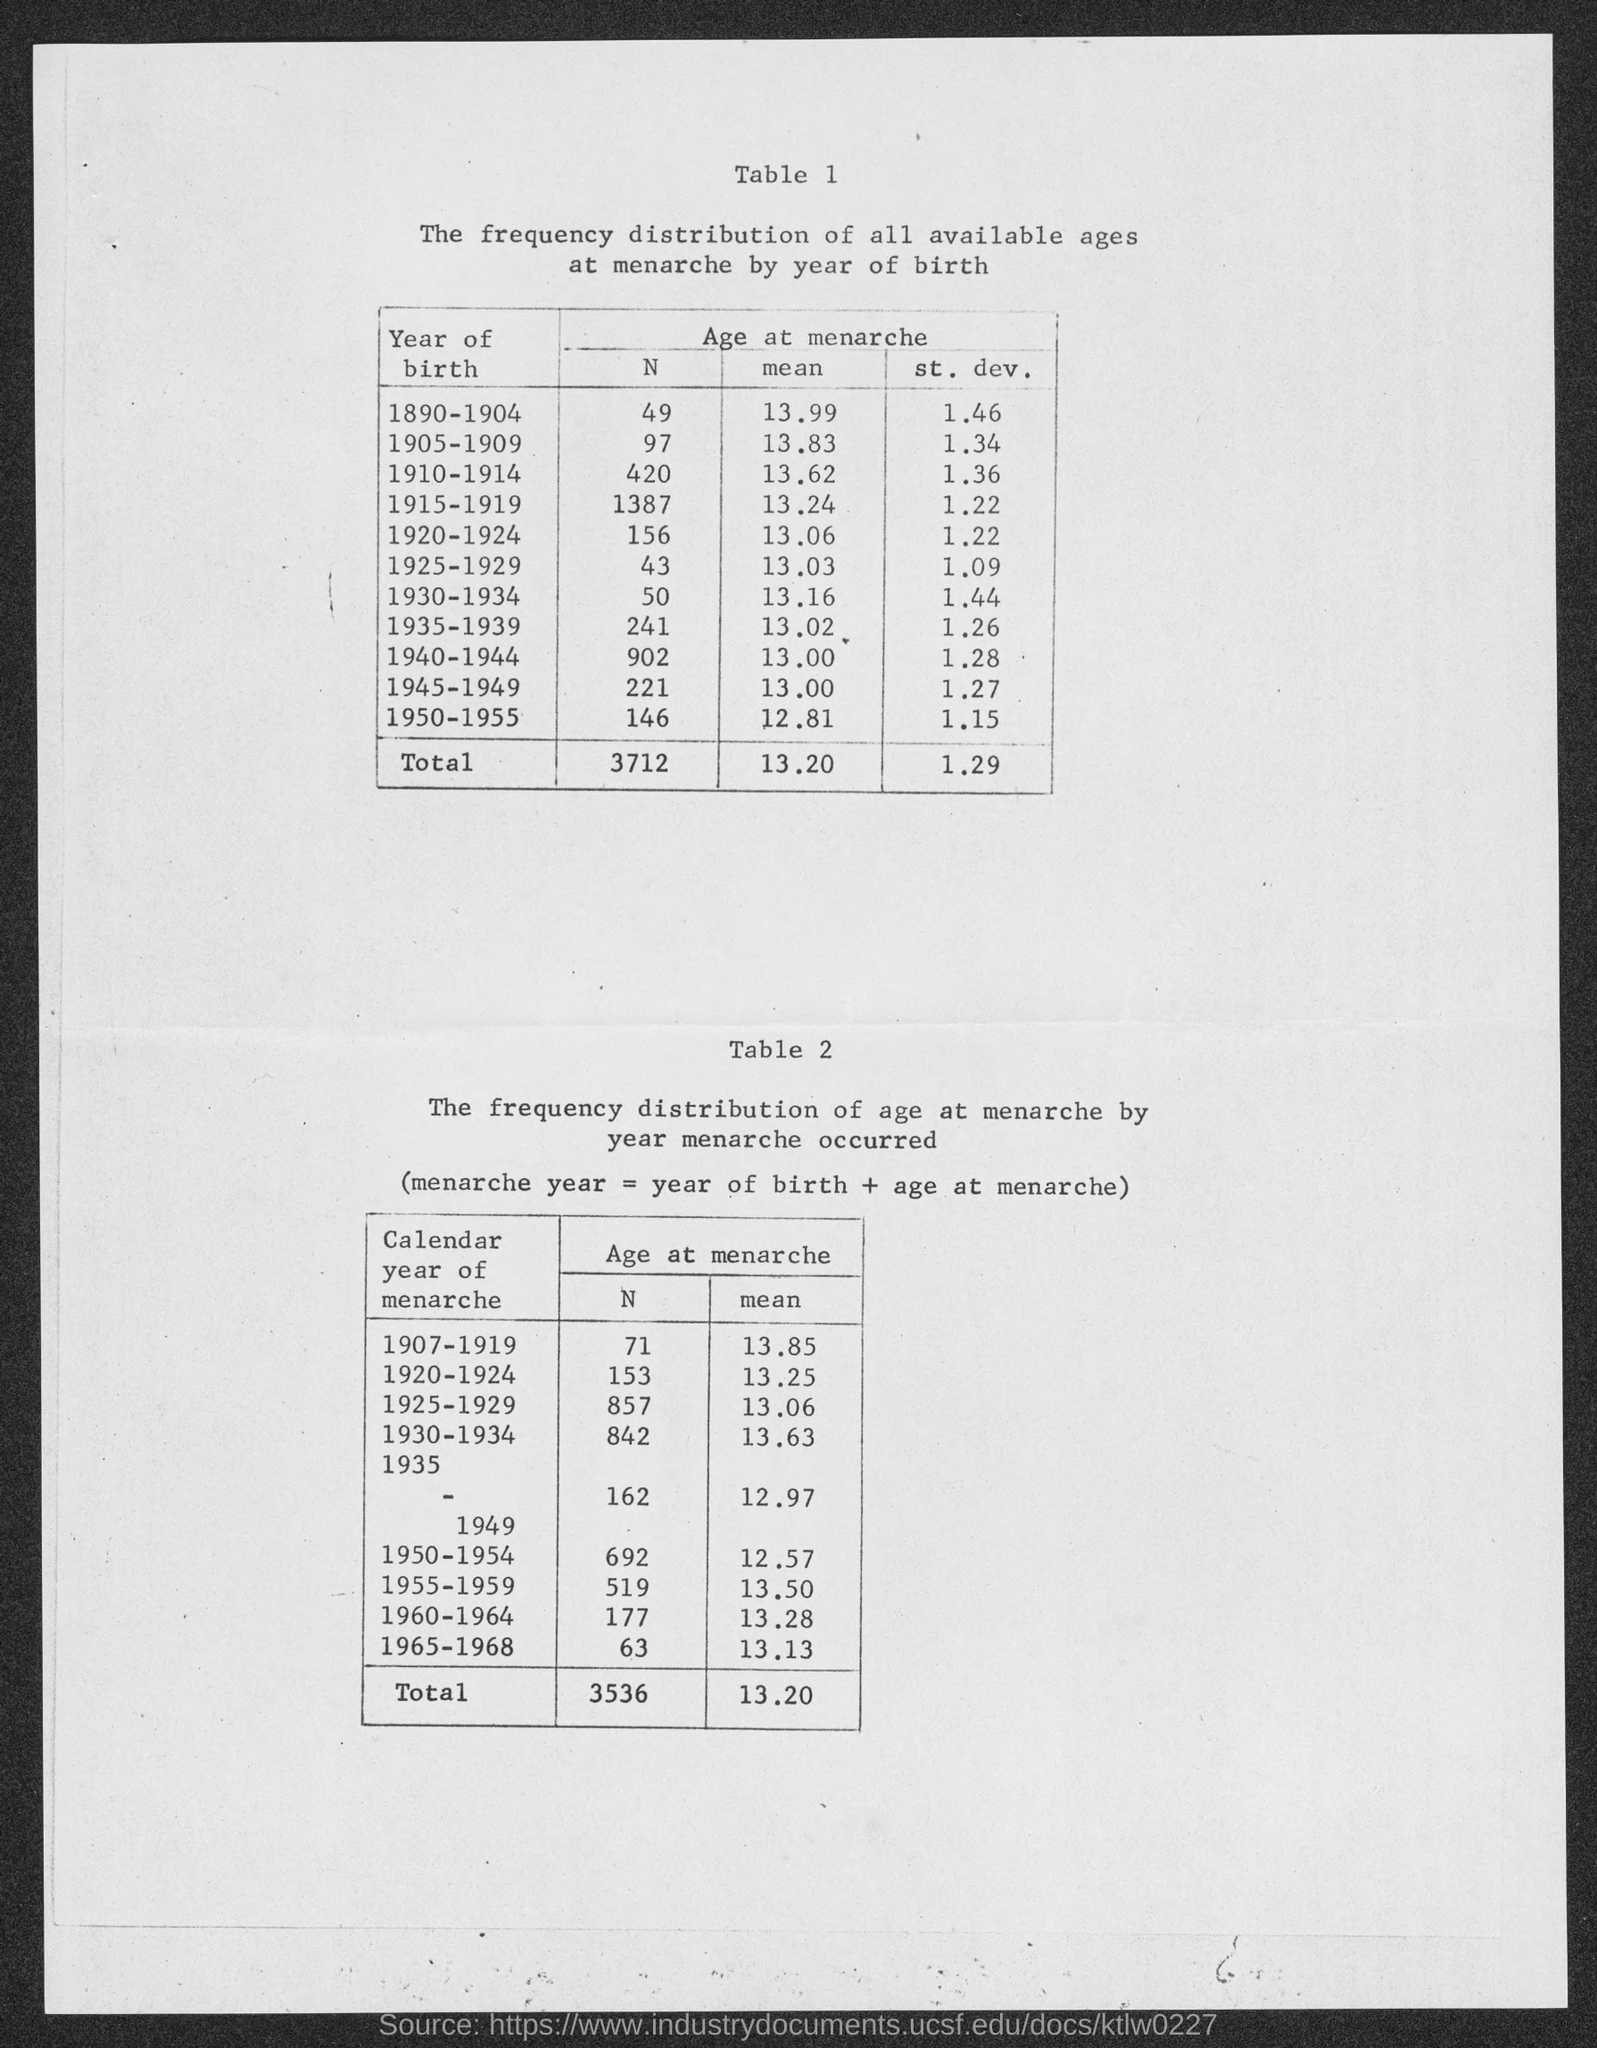Give some essential details in this illustration. The mean value for the year of birth for individuals born between 1890 and 1904 is approximately 13.99 years. The mean year of birth for individuals born between 1905 and 1909 is 13.83 years. The mean value for the year of birth between 1915 and 1919 is 1917. The total mean value mentioned in the given page is 13.20. 